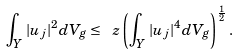Convert formula to latex. <formula><loc_0><loc_0><loc_500><loc_500>\int _ { Y } | u _ { j } | ^ { 2 } d V _ { g } \leq \ z \left ( \int _ { Y } | u _ { j } | ^ { 4 } d V _ { g } \right ) ^ { \frac { 1 } { 2 } } .</formula> 